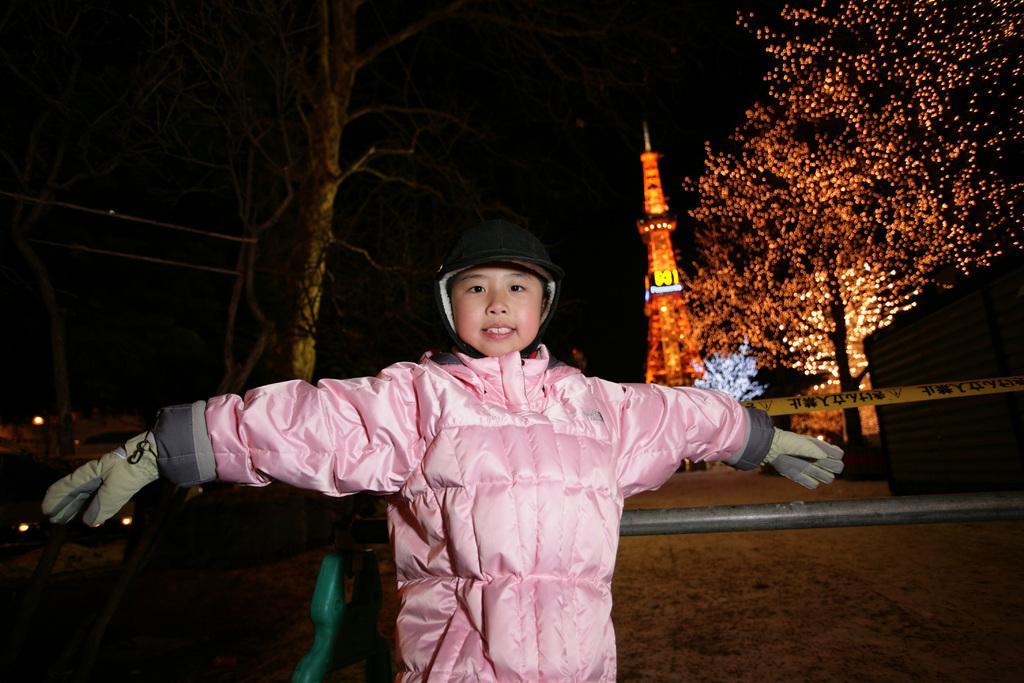How would you summarize this image in a sentence or two? In this image I can see a person wearing pink colored jacket and black colored hat is standing. In the background I can see few trees, few lights to the tree, a tower which is orange in color and the dark sky. 